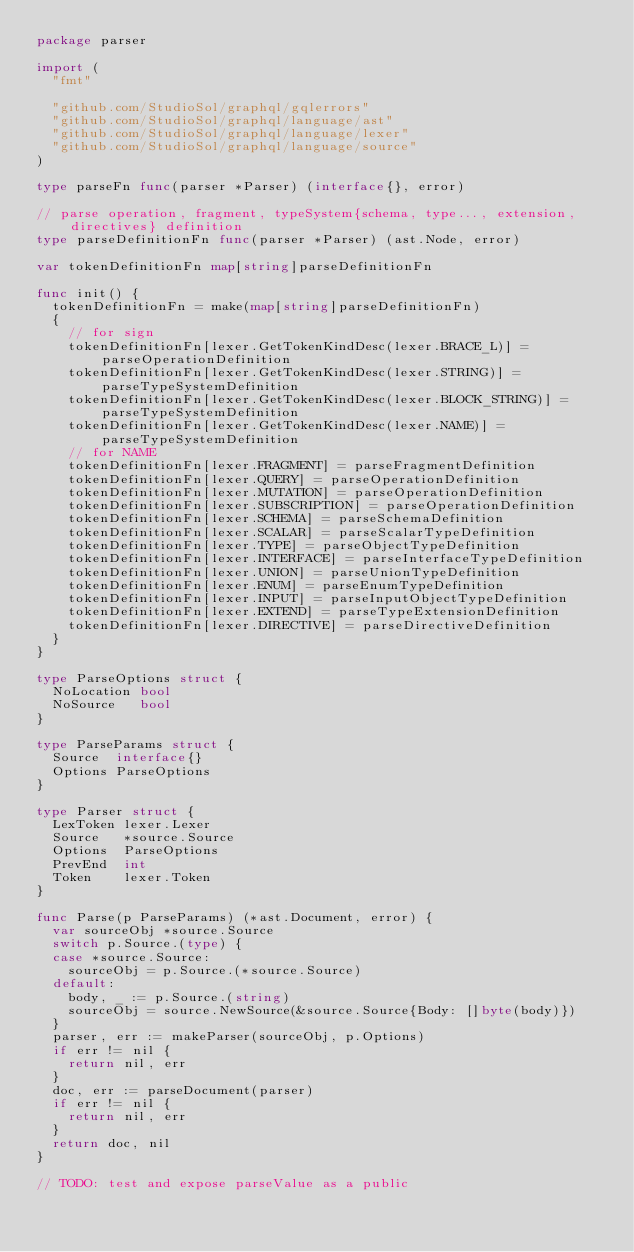Convert code to text. <code><loc_0><loc_0><loc_500><loc_500><_Go_>package parser

import (
	"fmt"

	"github.com/StudioSol/graphql/gqlerrors"
	"github.com/StudioSol/graphql/language/ast"
	"github.com/StudioSol/graphql/language/lexer"
	"github.com/StudioSol/graphql/language/source"
)

type parseFn func(parser *Parser) (interface{}, error)

// parse operation, fragment, typeSystem{schema, type..., extension, directives} definition
type parseDefinitionFn func(parser *Parser) (ast.Node, error)

var tokenDefinitionFn map[string]parseDefinitionFn

func init() {
	tokenDefinitionFn = make(map[string]parseDefinitionFn)
	{
		// for sign
		tokenDefinitionFn[lexer.GetTokenKindDesc(lexer.BRACE_L)] = parseOperationDefinition
		tokenDefinitionFn[lexer.GetTokenKindDesc(lexer.STRING)] = parseTypeSystemDefinition
		tokenDefinitionFn[lexer.GetTokenKindDesc(lexer.BLOCK_STRING)] = parseTypeSystemDefinition
		tokenDefinitionFn[lexer.GetTokenKindDesc(lexer.NAME)] = parseTypeSystemDefinition
		// for NAME
		tokenDefinitionFn[lexer.FRAGMENT] = parseFragmentDefinition
		tokenDefinitionFn[lexer.QUERY] = parseOperationDefinition
		tokenDefinitionFn[lexer.MUTATION] = parseOperationDefinition
		tokenDefinitionFn[lexer.SUBSCRIPTION] = parseOperationDefinition
		tokenDefinitionFn[lexer.SCHEMA] = parseSchemaDefinition
		tokenDefinitionFn[lexer.SCALAR] = parseScalarTypeDefinition
		tokenDefinitionFn[lexer.TYPE] = parseObjectTypeDefinition
		tokenDefinitionFn[lexer.INTERFACE] = parseInterfaceTypeDefinition
		tokenDefinitionFn[lexer.UNION] = parseUnionTypeDefinition
		tokenDefinitionFn[lexer.ENUM] = parseEnumTypeDefinition
		tokenDefinitionFn[lexer.INPUT] = parseInputObjectTypeDefinition
		tokenDefinitionFn[lexer.EXTEND] = parseTypeExtensionDefinition
		tokenDefinitionFn[lexer.DIRECTIVE] = parseDirectiveDefinition
	}
}

type ParseOptions struct {
	NoLocation bool
	NoSource   bool
}

type ParseParams struct {
	Source  interface{}
	Options ParseOptions
}

type Parser struct {
	LexToken lexer.Lexer
	Source   *source.Source
	Options  ParseOptions
	PrevEnd  int
	Token    lexer.Token
}

func Parse(p ParseParams) (*ast.Document, error) {
	var sourceObj *source.Source
	switch p.Source.(type) {
	case *source.Source:
		sourceObj = p.Source.(*source.Source)
	default:
		body, _ := p.Source.(string)
		sourceObj = source.NewSource(&source.Source{Body: []byte(body)})
	}
	parser, err := makeParser(sourceObj, p.Options)
	if err != nil {
		return nil, err
	}
	doc, err := parseDocument(parser)
	if err != nil {
		return nil, err
	}
	return doc, nil
}

// TODO: test and expose parseValue as a public</code> 